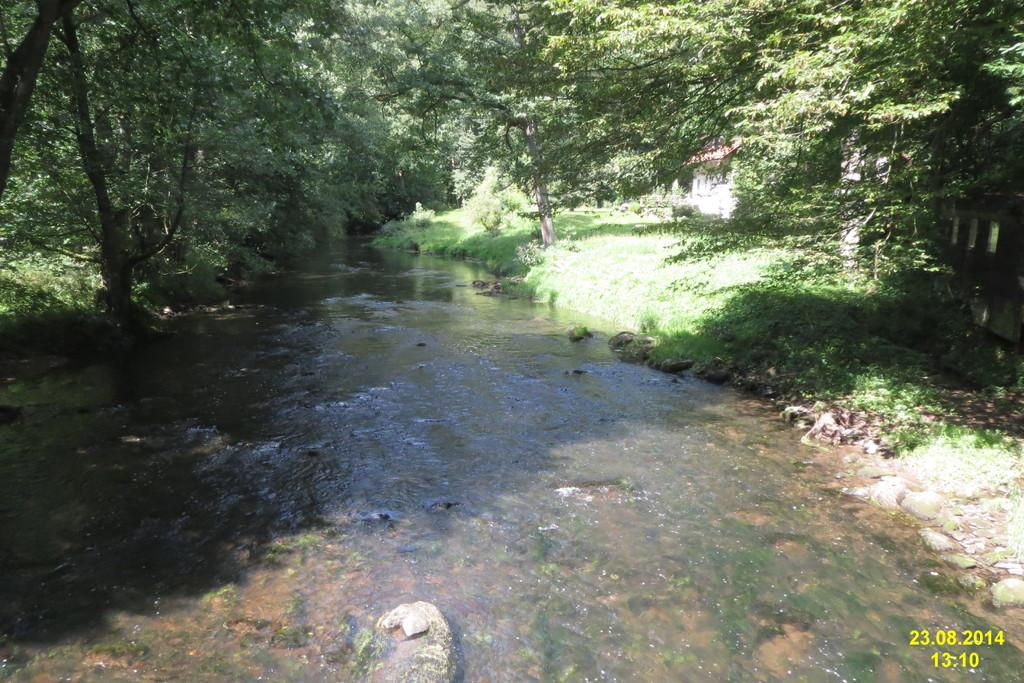What is happening on the surface in the image? There is water flowing on a surface in the image. What type of vegetation is present near the water surface? There is a lot of grass around the water surface. What other natural elements can be seen near the water surface? There are trees around the water surface. What rhythm does the creator of the image use to depict the water flow? The image is a photograph, not a creation, so there is no creator or rhythm involved in depicting the water flow. 